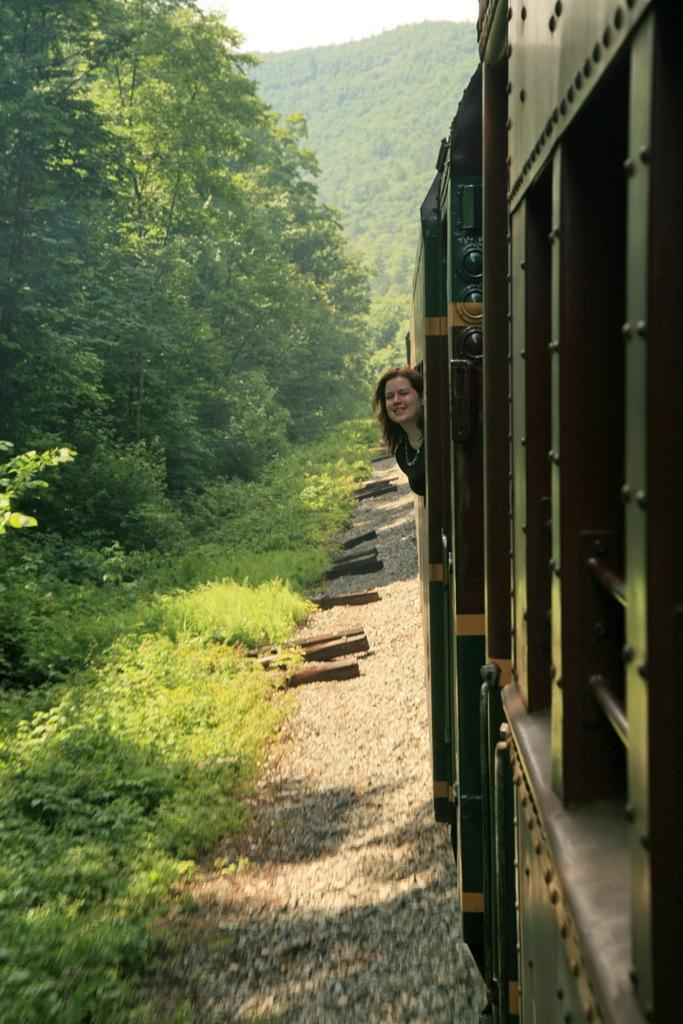What is inside the vehicle in the image? There is a person in the vehicle. What can be seen in the background of the image? There are plants and trees in the background of the image. What type of bread can be seen in the image? There is no bread present in the image. How does the fog affect the visibility of the trees in the image? There is no fog present in the image, so its effect on visibility cannot be determined. 